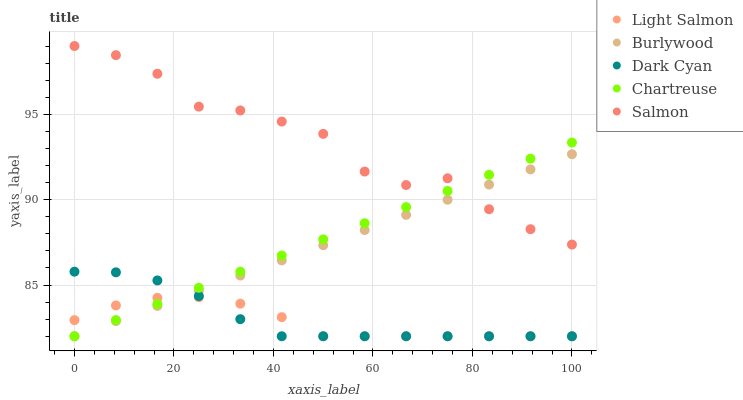Does Light Salmon have the minimum area under the curve?
Answer yes or no. Yes. Does Salmon have the maximum area under the curve?
Answer yes or no. Yes. Does Dark Cyan have the minimum area under the curve?
Answer yes or no. No. Does Dark Cyan have the maximum area under the curve?
Answer yes or no. No. Is Burlywood the smoothest?
Answer yes or no. Yes. Is Salmon the roughest?
Answer yes or no. Yes. Is Dark Cyan the smoothest?
Answer yes or no. No. Is Dark Cyan the roughest?
Answer yes or no. No. Does Burlywood have the lowest value?
Answer yes or no. Yes. Does Salmon have the lowest value?
Answer yes or no. No. Does Salmon have the highest value?
Answer yes or no. Yes. Does Dark Cyan have the highest value?
Answer yes or no. No. Is Light Salmon less than Salmon?
Answer yes or no. Yes. Is Salmon greater than Light Salmon?
Answer yes or no. Yes. Does Chartreuse intersect Dark Cyan?
Answer yes or no. Yes. Is Chartreuse less than Dark Cyan?
Answer yes or no. No. Is Chartreuse greater than Dark Cyan?
Answer yes or no. No. Does Light Salmon intersect Salmon?
Answer yes or no. No. 